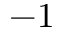Convert formula to latex. <formula><loc_0><loc_0><loc_500><loc_500>- 1</formula> 